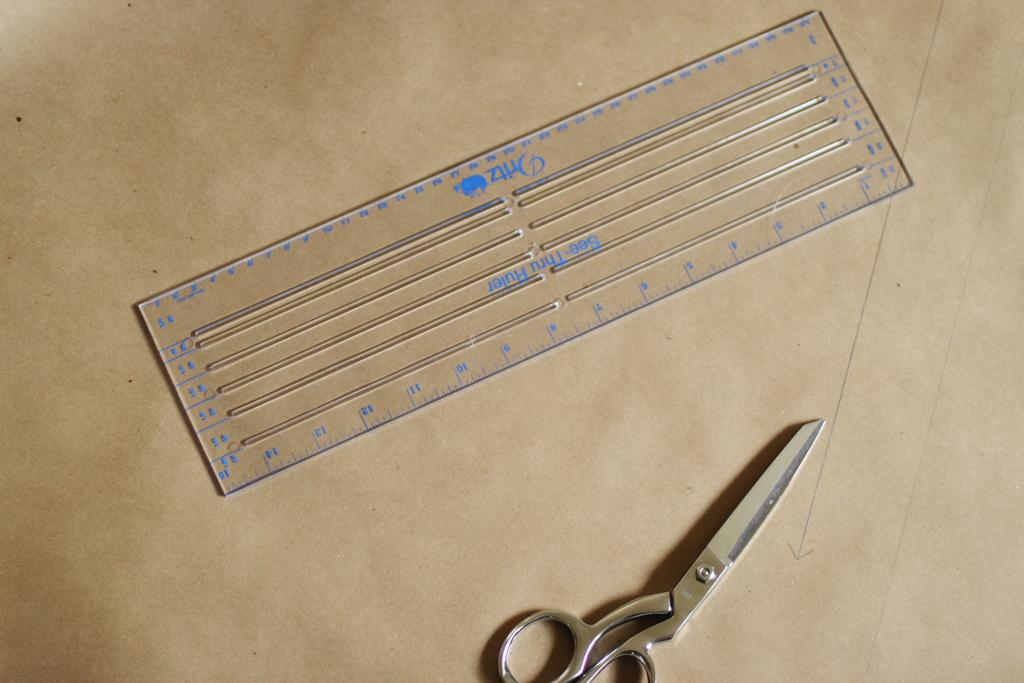<image>
Create a compact narrative representing the image presented. A clear Oritz see-through ruler laying on top of brown paper next to pair of scissors. 